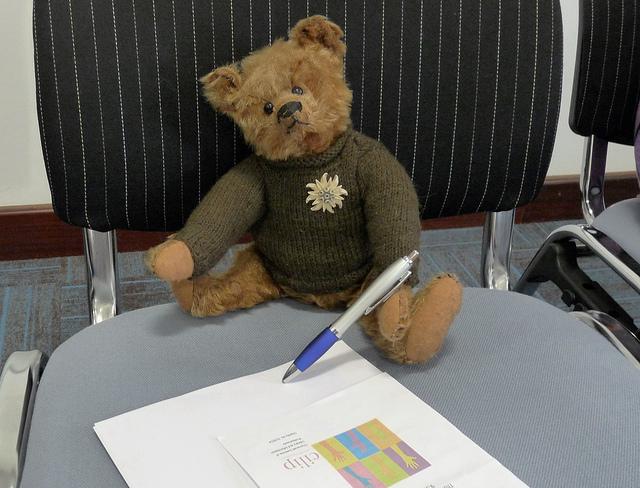What is the bear doing?
Keep it brief. Writing. Can the bear lick a stamp?
Keep it brief. No. Is the bear sad?
Keep it brief. Yes. 